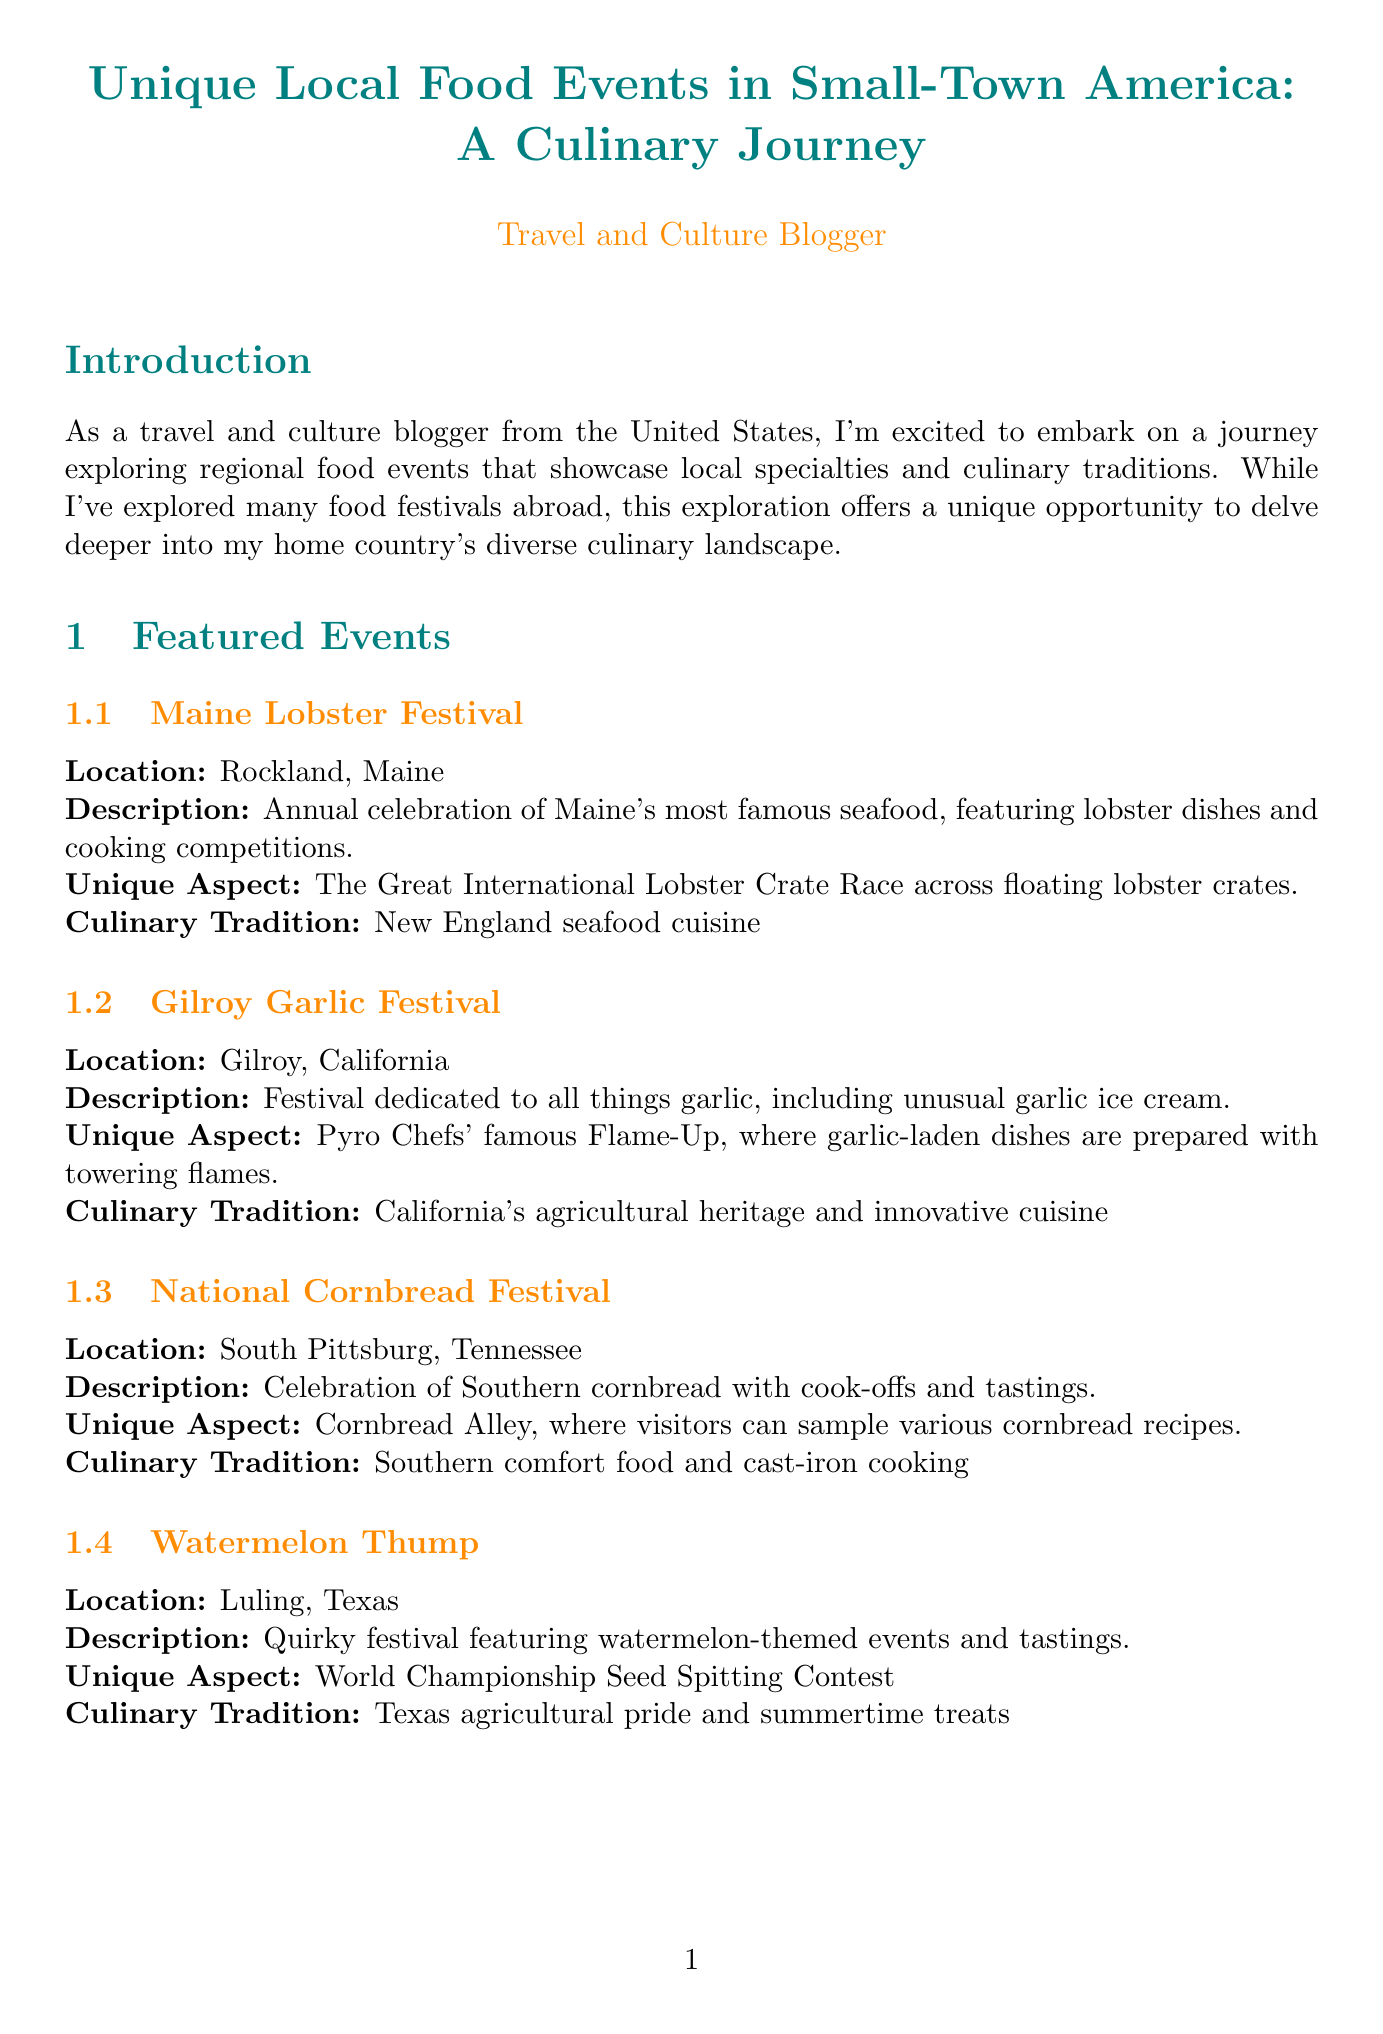What is the report title? The report title is stated at the beginning of the document to summarize its content.
Answer: Unique Local Food Events in Small-Town America: A Culinary Journey Which state hosts the Watermelon Thump? The document lists the location of each featured event, including the Watermelon Thump.
Answer: Texas What unique aspect is associated with the Maine Lobster Festival? Each event has a unique aspect described in the document, including the lobster festival.
Answer: The Great International Lobster Crate Race What culinary tradition is highlighted in the Gilroy Garlic Festival? Each festival is connected to a specific culinary tradition, and this one features California's heritage.
Answer: California's agricultural heritage and innovative cuisine How many featured events are listed in the report? The document enumerates the events presented in the "Featured Events" section.
Answer: Four What does the report indicate about regional differences in food events? The report draws attention to the contrasting types of food events depending on the region's focus.
Answer: Contrast between seafood-focused events in coastal areas and produce-centric festivals in agricultural regions What is a common aspect highlighted in the Economic Impact section? This section discusses various positive effects that events have on local communities.
Answer: Boost to restaurants, hotels, and artisanal food producers Which festival features a Seed Spitting Contest? This is specified within the descriptions of each featured event, and it's unique to one of them.
Answer: Watermelon Thump 